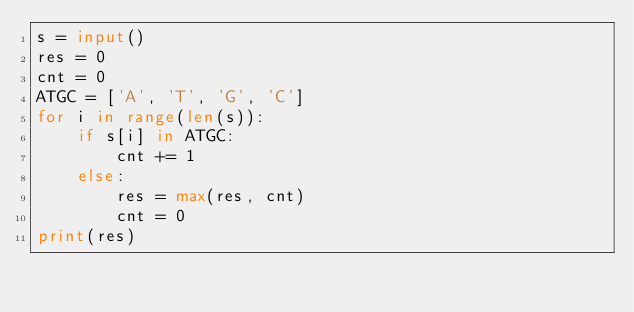Convert code to text. <code><loc_0><loc_0><loc_500><loc_500><_Python_>s = input()
res = 0
cnt = 0
ATGC = ['A', 'T', 'G', 'C']
for i in range(len(s)):
    if s[i] in ATGC:
        cnt += 1
    else:
        res = max(res, cnt)
        cnt = 0
print(res)</code> 